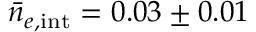<formula> <loc_0><loc_0><loc_500><loc_500>\bar { n } _ { e , { i n t } } = 0 . 0 3 \pm 0 . 0 1</formula> 